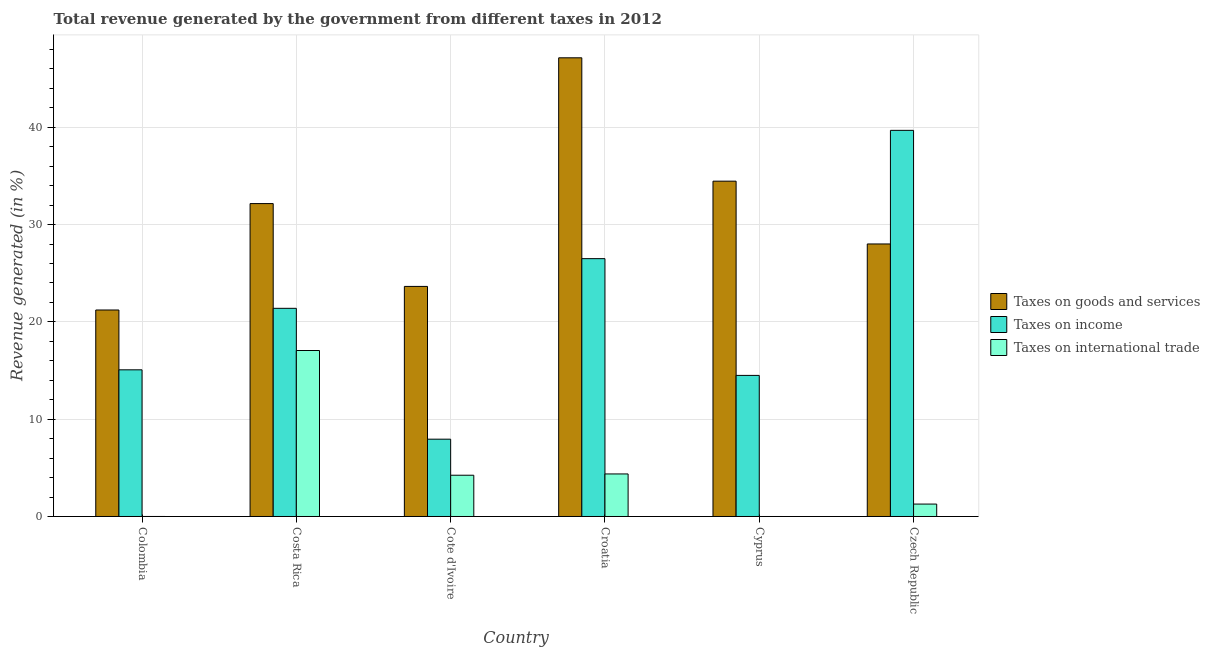Are the number of bars per tick equal to the number of legend labels?
Ensure brevity in your answer.  No. How many bars are there on the 3rd tick from the right?
Give a very brief answer. 3. What is the label of the 4th group of bars from the left?
Give a very brief answer. Croatia. In how many cases, is the number of bars for a given country not equal to the number of legend labels?
Ensure brevity in your answer.  1. What is the percentage of revenue generated by taxes on goods and services in Czech Republic?
Keep it short and to the point. 28. Across all countries, what is the maximum percentage of revenue generated by taxes on goods and services?
Keep it short and to the point. 47.13. Across all countries, what is the minimum percentage of revenue generated by taxes on income?
Give a very brief answer. 7.94. In which country was the percentage of revenue generated by taxes on income maximum?
Your answer should be compact. Czech Republic. What is the total percentage of revenue generated by taxes on income in the graph?
Your response must be concise. 125.08. What is the difference between the percentage of revenue generated by taxes on income in Colombia and that in Cote d'Ivoire?
Give a very brief answer. 7.13. What is the difference between the percentage of revenue generated by taxes on income in Cote d'Ivoire and the percentage of revenue generated by taxes on goods and services in Colombia?
Provide a succinct answer. -13.28. What is the average percentage of revenue generated by tax on international trade per country?
Make the answer very short. 4.49. What is the difference between the percentage of revenue generated by tax on international trade and percentage of revenue generated by taxes on goods and services in Colombia?
Your answer should be compact. -21.22. What is the ratio of the percentage of revenue generated by taxes on income in Cote d'Ivoire to that in Croatia?
Ensure brevity in your answer.  0.3. What is the difference between the highest and the second highest percentage of revenue generated by tax on international trade?
Make the answer very short. 12.68. What is the difference between the highest and the lowest percentage of revenue generated by taxes on goods and services?
Your response must be concise. 25.91. In how many countries, is the percentage of revenue generated by tax on international trade greater than the average percentage of revenue generated by tax on international trade taken over all countries?
Give a very brief answer. 1. Is it the case that in every country, the sum of the percentage of revenue generated by taxes on goods and services and percentage of revenue generated by taxes on income is greater than the percentage of revenue generated by tax on international trade?
Offer a very short reply. Yes. How many bars are there?
Offer a very short reply. 17. How many countries are there in the graph?
Make the answer very short. 6. What is the difference between two consecutive major ticks on the Y-axis?
Your response must be concise. 10. Are the values on the major ticks of Y-axis written in scientific E-notation?
Your answer should be very brief. No. Does the graph contain grids?
Your answer should be compact. Yes. Where does the legend appear in the graph?
Your answer should be compact. Center right. How many legend labels are there?
Keep it short and to the point. 3. What is the title of the graph?
Offer a terse response. Total revenue generated by the government from different taxes in 2012. What is the label or title of the X-axis?
Your answer should be very brief. Country. What is the label or title of the Y-axis?
Offer a terse response. Revenue generated (in %). What is the Revenue generated (in %) in Taxes on goods and services in Colombia?
Keep it short and to the point. 21.22. What is the Revenue generated (in %) in Taxes on income in Colombia?
Your response must be concise. 15.07. What is the Revenue generated (in %) in Taxes on international trade in Colombia?
Ensure brevity in your answer.  0. What is the Revenue generated (in %) of Taxes on goods and services in Costa Rica?
Your response must be concise. 32.15. What is the Revenue generated (in %) of Taxes on income in Costa Rica?
Provide a succinct answer. 21.39. What is the Revenue generated (in %) of Taxes on international trade in Costa Rica?
Give a very brief answer. 17.06. What is the Revenue generated (in %) in Taxes on goods and services in Cote d'Ivoire?
Give a very brief answer. 23.64. What is the Revenue generated (in %) in Taxes on income in Cote d'Ivoire?
Make the answer very short. 7.94. What is the Revenue generated (in %) in Taxes on international trade in Cote d'Ivoire?
Make the answer very short. 4.24. What is the Revenue generated (in %) of Taxes on goods and services in Croatia?
Keep it short and to the point. 47.13. What is the Revenue generated (in %) in Taxes on income in Croatia?
Your answer should be very brief. 26.5. What is the Revenue generated (in %) in Taxes on international trade in Croatia?
Ensure brevity in your answer.  4.37. What is the Revenue generated (in %) in Taxes on goods and services in Cyprus?
Make the answer very short. 34.46. What is the Revenue generated (in %) of Taxes on income in Cyprus?
Give a very brief answer. 14.5. What is the Revenue generated (in %) in Taxes on goods and services in Czech Republic?
Offer a terse response. 28. What is the Revenue generated (in %) in Taxes on income in Czech Republic?
Give a very brief answer. 39.68. What is the Revenue generated (in %) of Taxes on international trade in Czech Republic?
Your answer should be very brief. 1.28. Across all countries, what is the maximum Revenue generated (in %) in Taxes on goods and services?
Provide a succinct answer. 47.13. Across all countries, what is the maximum Revenue generated (in %) of Taxes on income?
Provide a succinct answer. 39.68. Across all countries, what is the maximum Revenue generated (in %) of Taxes on international trade?
Provide a succinct answer. 17.06. Across all countries, what is the minimum Revenue generated (in %) of Taxes on goods and services?
Ensure brevity in your answer.  21.22. Across all countries, what is the minimum Revenue generated (in %) of Taxes on income?
Your answer should be very brief. 7.94. Across all countries, what is the minimum Revenue generated (in %) in Taxes on international trade?
Keep it short and to the point. 0. What is the total Revenue generated (in %) of Taxes on goods and services in the graph?
Your answer should be very brief. 186.61. What is the total Revenue generated (in %) of Taxes on income in the graph?
Give a very brief answer. 125.08. What is the total Revenue generated (in %) of Taxes on international trade in the graph?
Give a very brief answer. 26.94. What is the difference between the Revenue generated (in %) in Taxes on goods and services in Colombia and that in Costa Rica?
Make the answer very short. -10.93. What is the difference between the Revenue generated (in %) of Taxes on income in Colombia and that in Costa Rica?
Make the answer very short. -6.32. What is the difference between the Revenue generated (in %) of Taxes on international trade in Colombia and that in Costa Rica?
Provide a succinct answer. -17.06. What is the difference between the Revenue generated (in %) of Taxes on goods and services in Colombia and that in Cote d'Ivoire?
Your response must be concise. -2.42. What is the difference between the Revenue generated (in %) of Taxes on income in Colombia and that in Cote d'Ivoire?
Offer a very short reply. 7.13. What is the difference between the Revenue generated (in %) of Taxes on international trade in Colombia and that in Cote d'Ivoire?
Make the answer very short. -4.24. What is the difference between the Revenue generated (in %) in Taxes on goods and services in Colombia and that in Croatia?
Your response must be concise. -25.91. What is the difference between the Revenue generated (in %) of Taxes on income in Colombia and that in Croatia?
Keep it short and to the point. -11.42. What is the difference between the Revenue generated (in %) of Taxes on international trade in Colombia and that in Croatia?
Your response must be concise. -4.37. What is the difference between the Revenue generated (in %) in Taxes on goods and services in Colombia and that in Cyprus?
Make the answer very short. -13.24. What is the difference between the Revenue generated (in %) in Taxes on income in Colombia and that in Cyprus?
Keep it short and to the point. 0.57. What is the difference between the Revenue generated (in %) of Taxes on goods and services in Colombia and that in Czech Republic?
Provide a short and direct response. -6.79. What is the difference between the Revenue generated (in %) of Taxes on income in Colombia and that in Czech Republic?
Offer a very short reply. -24.61. What is the difference between the Revenue generated (in %) of Taxes on international trade in Colombia and that in Czech Republic?
Provide a short and direct response. -1.28. What is the difference between the Revenue generated (in %) in Taxes on goods and services in Costa Rica and that in Cote d'Ivoire?
Make the answer very short. 8.51. What is the difference between the Revenue generated (in %) of Taxes on income in Costa Rica and that in Cote d'Ivoire?
Provide a short and direct response. 13.45. What is the difference between the Revenue generated (in %) of Taxes on international trade in Costa Rica and that in Cote d'Ivoire?
Offer a very short reply. 12.82. What is the difference between the Revenue generated (in %) in Taxes on goods and services in Costa Rica and that in Croatia?
Provide a succinct answer. -14.98. What is the difference between the Revenue generated (in %) of Taxes on income in Costa Rica and that in Croatia?
Your answer should be compact. -5.1. What is the difference between the Revenue generated (in %) in Taxes on international trade in Costa Rica and that in Croatia?
Your answer should be compact. 12.68. What is the difference between the Revenue generated (in %) in Taxes on goods and services in Costa Rica and that in Cyprus?
Provide a short and direct response. -2.3. What is the difference between the Revenue generated (in %) in Taxes on income in Costa Rica and that in Cyprus?
Make the answer very short. 6.89. What is the difference between the Revenue generated (in %) of Taxes on goods and services in Costa Rica and that in Czech Republic?
Keep it short and to the point. 4.15. What is the difference between the Revenue generated (in %) in Taxes on income in Costa Rica and that in Czech Republic?
Provide a short and direct response. -18.29. What is the difference between the Revenue generated (in %) in Taxes on international trade in Costa Rica and that in Czech Republic?
Your answer should be very brief. 15.78. What is the difference between the Revenue generated (in %) of Taxes on goods and services in Cote d'Ivoire and that in Croatia?
Your response must be concise. -23.49. What is the difference between the Revenue generated (in %) in Taxes on income in Cote d'Ivoire and that in Croatia?
Offer a very short reply. -18.55. What is the difference between the Revenue generated (in %) in Taxes on international trade in Cote d'Ivoire and that in Croatia?
Keep it short and to the point. -0.13. What is the difference between the Revenue generated (in %) of Taxes on goods and services in Cote d'Ivoire and that in Cyprus?
Keep it short and to the point. -10.82. What is the difference between the Revenue generated (in %) of Taxes on income in Cote d'Ivoire and that in Cyprus?
Your answer should be compact. -6.55. What is the difference between the Revenue generated (in %) in Taxes on goods and services in Cote d'Ivoire and that in Czech Republic?
Make the answer very short. -4.36. What is the difference between the Revenue generated (in %) of Taxes on income in Cote d'Ivoire and that in Czech Republic?
Provide a succinct answer. -31.73. What is the difference between the Revenue generated (in %) in Taxes on international trade in Cote d'Ivoire and that in Czech Republic?
Your answer should be very brief. 2.96. What is the difference between the Revenue generated (in %) in Taxes on goods and services in Croatia and that in Cyprus?
Offer a terse response. 12.68. What is the difference between the Revenue generated (in %) of Taxes on income in Croatia and that in Cyprus?
Your answer should be very brief. 12. What is the difference between the Revenue generated (in %) of Taxes on goods and services in Croatia and that in Czech Republic?
Your answer should be compact. 19.13. What is the difference between the Revenue generated (in %) of Taxes on income in Croatia and that in Czech Republic?
Provide a succinct answer. -13.18. What is the difference between the Revenue generated (in %) of Taxes on international trade in Croatia and that in Czech Republic?
Make the answer very short. 3.1. What is the difference between the Revenue generated (in %) of Taxes on goods and services in Cyprus and that in Czech Republic?
Keep it short and to the point. 6.45. What is the difference between the Revenue generated (in %) in Taxes on income in Cyprus and that in Czech Republic?
Provide a short and direct response. -25.18. What is the difference between the Revenue generated (in %) in Taxes on goods and services in Colombia and the Revenue generated (in %) in Taxes on income in Costa Rica?
Keep it short and to the point. -0.17. What is the difference between the Revenue generated (in %) in Taxes on goods and services in Colombia and the Revenue generated (in %) in Taxes on international trade in Costa Rica?
Make the answer very short. 4.16. What is the difference between the Revenue generated (in %) of Taxes on income in Colombia and the Revenue generated (in %) of Taxes on international trade in Costa Rica?
Ensure brevity in your answer.  -1.98. What is the difference between the Revenue generated (in %) in Taxes on goods and services in Colombia and the Revenue generated (in %) in Taxes on income in Cote d'Ivoire?
Your answer should be very brief. 13.28. What is the difference between the Revenue generated (in %) of Taxes on goods and services in Colombia and the Revenue generated (in %) of Taxes on international trade in Cote d'Ivoire?
Ensure brevity in your answer.  16.98. What is the difference between the Revenue generated (in %) of Taxes on income in Colombia and the Revenue generated (in %) of Taxes on international trade in Cote d'Ivoire?
Provide a succinct answer. 10.83. What is the difference between the Revenue generated (in %) in Taxes on goods and services in Colombia and the Revenue generated (in %) in Taxes on income in Croatia?
Your answer should be compact. -5.28. What is the difference between the Revenue generated (in %) in Taxes on goods and services in Colombia and the Revenue generated (in %) in Taxes on international trade in Croatia?
Make the answer very short. 16.85. What is the difference between the Revenue generated (in %) of Taxes on income in Colombia and the Revenue generated (in %) of Taxes on international trade in Croatia?
Offer a very short reply. 10.7. What is the difference between the Revenue generated (in %) in Taxes on goods and services in Colombia and the Revenue generated (in %) in Taxes on income in Cyprus?
Offer a very short reply. 6.72. What is the difference between the Revenue generated (in %) of Taxes on goods and services in Colombia and the Revenue generated (in %) of Taxes on income in Czech Republic?
Your response must be concise. -18.46. What is the difference between the Revenue generated (in %) in Taxes on goods and services in Colombia and the Revenue generated (in %) in Taxes on international trade in Czech Republic?
Offer a terse response. 19.94. What is the difference between the Revenue generated (in %) in Taxes on income in Colombia and the Revenue generated (in %) in Taxes on international trade in Czech Republic?
Your answer should be very brief. 13.79. What is the difference between the Revenue generated (in %) in Taxes on goods and services in Costa Rica and the Revenue generated (in %) in Taxes on income in Cote d'Ivoire?
Your answer should be compact. 24.21. What is the difference between the Revenue generated (in %) in Taxes on goods and services in Costa Rica and the Revenue generated (in %) in Taxes on international trade in Cote d'Ivoire?
Provide a short and direct response. 27.91. What is the difference between the Revenue generated (in %) of Taxes on income in Costa Rica and the Revenue generated (in %) of Taxes on international trade in Cote d'Ivoire?
Ensure brevity in your answer.  17.15. What is the difference between the Revenue generated (in %) of Taxes on goods and services in Costa Rica and the Revenue generated (in %) of Taxes on income in Croatia?
Your response must be concise. 5.66. What is the difference between the Revenue generated (in %) of Taxes on goods and services in Costa Rica and the Revenue generated (in %) of Taxes on international trade in Croatia?
Keep it short and to the point. 27.78. What is the difference between the Revenue generated (in %) in Taxes on income in Costa Rica and the Revenue generated (in %) in Taxes on international trade in Croatia?
Make the answer very short. 17.02. What is the difference between the Revenue generated (in %) in Taxes on goods and services in Costa Rica and the Revenue generated (in %) in Taxes on income in Cyprus?
Your answer should be compact. 17.66. What is the difference between the Revenue generated (in %) of Taxes on goods and services in Costa Rica and the Revenue generated (in %) of Taxes on income in Czech Republic?
Your response must be concise. -7.53. What is the difference between the Revenue generated (in %) in Taxes on goods and services in Costa Rica and the Revenue generated (in %) in Taxes on international trade in Czech Republic?
Keep it short and to the point. 30.88. What is the difference between the Revenue generated (in %) in Taxes on income in Costa Rica and the Revenue generated (in %) in Taxes on international trade in Czech Republic?
Provide a succinct answer. 20.11. What is the difference between the Revenue generated (in %) in Taxes on goods and services in Cote d'Ivoire and the Revenue generated (in %) in Taxes on income in Croatia?
Your answer should be compact. -2.85. What is the difference between the Revenue generated (in %) in Taxes on goods and services in Cote d'Ivoire and the Revenue generated (in %) in Taxes on international trade in Croatia?
Your answer should be very brief. 19.27. What is the difference between the Revenue generated (in %) in Taxes on income in Cote d'Ivoire and the Revenue generated (in %) in Taxes on international trade in Croatia?
Give a very brief answer. 3.57. What is the difference between the Revenue generated (in %) of Taxes on goods and services in Cote d'Ivoire and the Revenue generated (in %) of Taxes on income in Cyprus?
Provide a short and direct response. 9.14. What is the difference between the Revenue generated (in %) of Taxes on goods and services in Cote d'Ivoire and the Revenue generated (in %) of Taxes on income in Czech Republic?
Ensure brevity in your answer.  -16.04. What is the difference between the Revenue generated (in %) in Taxes on goods and services in Cote d'Ivoire and the Revenue generated (in %) in Taxes on international trade in Czech Republic?
Provide a short and direct response. 22.37. What is the difference between the Revenue generated (in %) of Taxes on income in Cote d'Ivoire and the Revenue generated (in %) of Taxes on international trade in Czech Republic?
Provide a succinct answer. 6.67. What is the difference between the Revenue generated (in %) of Taxes on goods and services in Croatia and the Revenue generated (in %) of Taxes on income in Cyprus?
Your answer should be very brief. 32.63. What is the difference between the Revenue generated (in %) of Taxes on goods and services in Croatia and the Revenue generated (in %) of Taxes on income in Czech Republic?
Provide a succinct answer. 7.45. What is the difference between the Revenue generated (in %) of Taxes on goods and services in Croatia and the Revenue generated (in %) of Taxes on international trade in Czech Republic?
Provide a succinct answer. 45.86. What is the difference between the Revenue generated (in %) of Taxes on income in Croatia and the Revenue generated (in %) of Taxes on international trade in Czech Republic?
Keep it short and to the point. 25.22. What is the difference between the Revenue generated (in %) in Taxes on goods and services in Cyprus and the Revenue generated (in %) in Taxes on income in Czech Republic?
Offer a terse response. -5.22. What is the difference between the Revenue generated (in %) of Taxes on goods and services in Cyprus and the Revenue generated (in %) of Taxes on international trade in Czech Republic?
Your response must be concise. 33.18. What is the difference between the Revenue generated (in %) of Taxes on income in Cyprus and the Revenue generated (in %) of Taxes on international trade in Czech Republic?
Ensure brevity in your answer.  13.22. What is the average Revenue generated (in %) in Taxes on goods and services per country?
Your answer should be very brief. 31.1. What is the average Revenue generated (in %) in Taxes on income per country?
Ensure brevity in your answer.  20.85. What is the average Revenue generated (in %) in Taxes on international trade per country?
Offer a very short reply. 4.49. What is the difference between the Revenue generated (in %) in Taxes on goods and services and Revenue generated (in %) in Taxes on income in Colombia?
Give a very brief answer. 6.15. What is the difference between the Revenue generated (in %) in Taxes on goods and services and Revenue generated (in %) in Taxes on international trade in Colombia?
Make the answer very short. 21.22. What is the difference between the Revenue generated (in %) in Taxes on income and Revenue generated (in %) in Taxes on international trade in Colombia?
Ensure brevity in your answer.  15.07. What is the difference between the Revenue generated (in %) in Taxes on goods and services and Revenue generated (in %) in Taxes on income in Costa Rica?
Provide a succinct answer. 10.76. What is the difference between the Revenue generated (in %) of Taxes on goods and services and Revenue generated (in %) of Taxes on international trade in Costa Rica?
Your response must be concise. 15.1. What is the difference between the Revenue generated (in %) in Taxes on income and Revenue generated (in %) in Taxes on international trade in Costa Rica?
Offer a terse response. 4.34. What is the difference between the Revenue generated (in %) in Taxes on goods and services and Revenue generated (in %) in Taxes on income in Cote d'Ivoire?
Make the answer very short. 15.7. What is the difference between the Revenue generated (in %) of Taxes on goods and services and Revenue generated (in %) of Taxes on international trade in Cote d'Ivoire?
Ensure brevity in your answer.  19.4. What is the difference between the Revenue generated (in %) of Taxes on income and Revenue generated (in %) of Taxes on international trade in Cote d'Ivoire?
Give a very brief answer. 3.7. What is the difference between the Revenue generated (in %) of Taxes on goods and services and Revenue generated (in %) of Taxes on income in Croatia?
Your answer should be compact. 20.64. What is the difference between the Revenue generated (in %) in Taxes on goods and services and Revenue generated (in %) in Taxes on international trade in Croatia?
Keep it short and to the point. 42.76. What is the difference between the Revenue generated (in %) of Taxes on income and Revenue generated (in %) of Taxes on international trade in Croatia?
Ensure brevity in your answer.  22.12. What is the difference between the Revenue generated (in %) of Taxes on goods and services and Revenue generated (in %) of Taxes on income in Cyprus?
Provide a succinct answer. 19.96. What is the difference between the Revenue generated (in %) in Taxes on goods and services and Revenue generated (in %) in Taxes on income in Czech Republic?
Give a very brief answer. -11.67. What is the difference between the Revenue generated (in %) of Taxes on goods and services and Revenue generated (in %) of Taxes on international trade in Czech Republic?
Provide a succinct answer. 26.73. What is the difference between the Revenue generated (in %) in Taxes on income and Revenue generated (in %) in Taxes on international trade in Czech Republic?
Provide a short and direct response. 38.4. What is the ratio of the Revenue generated (in %) in Taxes on goods and services in Colombia to that in Costa Rica?
Your response must be concise. 0.66. What is the ratio of the Revenue generated (in %) of Taxes on income in Colombia to that in Costa Rica?
Give a very brief answer. 0.7. What is the ratio of the Revenue generated (in %) in Taxes on international trade in Colombia to that in Costa Rica?
Keep it short and to the point. 0. What is the ratio of the Revenue generated (in %) of Taxes on goods and services in Colombia to that in Cote d'Ivoire?
Offer a very short reply. 0.9. What is the ratio of the Revenue generated (in %) of Taxes on income in Colombia to that in Cote d'Ivoire?
Keep it short and to the point. 1.9. What is the ratio of the Revenue generated (in %) in Taxes on goods and services in Colombia to that in Croatia?
Your answer should be compact. 0.45. What is the ratio of the Revenue generated (in %) of Taxes on income in Colombia to that in Croatia?
Ensure brevity in your answer.  0.57. What is the ratio of the Revenue generated (in %) of Taxes on international trade in Colombia to that in Croatia?
Give a very brief answer. 0. What is the ratio of the Revenue generated (in %) of Taxes on goods and services in Colombia to that in Cyprus?
Provide a succinct answer. 0.62. What is the ratio of the Revenue generated (in %) in Taxes on income in Colombia to that in Cyprus?
Offer a terse response. 1.04. What is the ratio of the Revenue generated (in %) in Taxes on goods and services in Colombia to that in Czech Republic?
Offer a terse response. 0.76. What is the ratio of the Revenue generated (in %) in Taxes on income in Colombia to that in Czech Republic?
Provide a short and direct response. 0.38. What is the ratio of the Revenue generated (in %) of Taxes on goods and services in Costa Rica to that in Cote d'Ivoire?
Your answer should be compact. 1.36. What is the ratio of the Revenue generated (in %) of Taxes on income in Costa Rica to that in Cote d'Ivoire?
Offer a very short reply. 2.69. What is the ratio of the Revenue generated (in %) in Taxes on international trade in Costa Rica to that in Cote d'Ivoire?
Keep it short and to the point. 4.02. What is the ratio of the Revenue generated (in %) of Taxes on goods and services in Costa Rica to that in Croatia?
Your response must be concise. 0.68. What is the ratio of the Revenue generated (in %) in Taxes on income in Costa Rica to that in Croatia?
Give a very brief answer. 0.81. What is the ratio of the Revenue generated (in %) in Taxes on international trade in Costa Rica to that in Croatia?
Give a very brief answer. 3.9. What is the ratio of the Revenue generated (in %) in Taxes on goods and services in Costa Rica to that in Cyprus?
Your answer should be very brief. 0.93. What is the ratio of the Revenue generated (in %) of Taxes on income in Costa Rica to that in Cyprus?
Keep it short and to the point. 1.48. What is the ratio of the Revenue generated (in %) of Taxes on goods and services in Costa Rica to that in Czech Republic?
Keep it short and to the point. 1.15. What is the ratio of the Revenue generated (in %) in Taxes on income in Costa Rica to that in Czech Republic?
Provide a succinct answer. 0.54. What is the ratio of the Revenue generated (in %) of Taxes on international trade in Costa Rica to that in Czech Republic?
Provide a short and direct response. 13.36. What is the ratio of the Revenue generated (in %) in Taxes on goods and services in Cote d'Ivoire to that in Croatia?
Give a very brief answer. 0.5. What is the ratio of the Revenue generated (in %) in Taxes on income in Cote d'Ivoire to that in Croatia?
Your answer should be compact. 0.3. What is the ratio of the Revenue generated (in %) in Taxes on international trade in Cote d'Ivoire to that in Croatia?
Keep it short and to the point. 0.97. What is the ratio of the Revenue generated (in %) in Taxes on goods and services in Cote d'Ivoire to that in Cyprus?
Your answer should be very brief. 0.69. What is the ratio of the Revenue generated (in %) in Taxes on income in Cote d'Ivoire to that in Cyprus?
Your answer should be compact. 0.55. What is the ratio of the Revenue generated (in %) in Taxes on goods and services in Cote d'Ivoire to that in Czech Republic?
Keep it short and to the point. 0.84. What is the ratio of the Revenue generated (in %) of Taxes on income in Cote d'Ivoire to that in Czech Republic?
Your response must be concise. 0.2. What is the ratio of the Revenue generated (in %) in Taxes on international trade in Cote d'Ivoire to that in Czech Republic?
Provide a short and direct response. 3.32. What is the ratio of the Revenue generated (in %) of Taxes on goods and services in Croatia to that in Cyprus?
Provide a succinct answer. 1.37. What is the ratio of the Revenue generated (in %) in Taxes on income in Croatia to that in Cyprus?
Keep it short and to the point. 1.83. What is the ratio of the Revenue generated (in %) in Taxes on goods and services in Croatia to that in Czech Republic?
Provide a succinct answer. 1.68. What is the ratio of the Revenue generated (in %) in Taxes on income in Croatia to that in Czech Republic?
Your response must be concise. 0.67. What is the ratio of the Revenue generated (in %) in Taxes on international trade in Croatia to that in Czech Republic?
Keep it short and to the point. 3.42. What is the ratio of the Revenue generated (in %) of Taxes on goods and services in Cyprus to that in Czech Republic?
Ensure brevity in your answer.  1.23. What is the ratio of the Revenue generated (in %) of Taxes on income in Cyprus to that in Czech Republic?
Provide a short and direct response. 0.37. What is the difference between the highest and the second highest Revenue generated (in %) in Taxes on goods and services?
Your response must be concise. 12.68. What is the difference between the highest and the second highest Revenue generated (in %) of Taxes on income?
Ensure brevity in your answer.  13.18. What is the difference between the highest and the second highest Revenue generated (in %) of Taxes on international trade?
Keep it short and to the point. 12.68. What is the difference between the highest and the lowest Revenue generated (in %) of Taxes on goods and services?
Your response must be concise. 25.91. What is the difference between the highest and the lowest Revenue generated (in %) of Taxes on income?
Provide a succinct answer. 31.73. What is the difference between the highest and the lowest Revenue generated (in %) of Taxes on international trade?
Offer a very short reply. 17.06. 